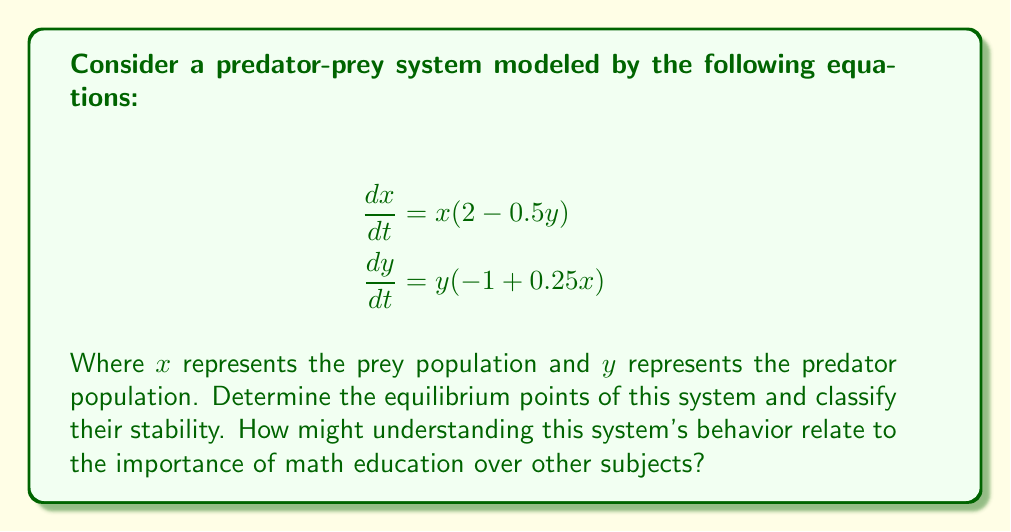What is the answer to this math problem? 1. Find the equilibrium points by setting both equations to zero:

   $$x(2 - 0.5y) = 0$$
   $$y(-1 + 0.25x) = 0$$

2. Solve these equations:
   a) From the first equation, either $x = 0$ or $2 - 0.5y = 0$
   b) From the second equation, either $y = 0$ or $-1 + 0.25x = 0$

3. Combining these conditions, we get two equilibrium points:
   - $(0, 0)$
   - $(4, 4)$

4. To classify stability, we need to find the Jacobian matrix:

   $$J = \begin{bmatrix}
   \frac{\partial}{\partial x}(x(2-0.5y)) & \frac{\partial}{\partial y}(x(2-0.5y)) \\
   \frac{\partial}{\partial x}(y(-1+0.25x)) & \frac{\partial}{\partial y}(y(-1+0.25x))
   \end{bmatrix}$$

   $$J = \begin{bmatrix}
   2-0.5y & -0.5x \\
   0.25y & -1+0.25x
   \end{bmatrix}$$

5. Evaluate J at (0, 0):
   
   $$J_{(0,0)} = \begin{bmatrix}
   2 & 0 \\
   0 & -1
   \end{bmatrix}$$

   Eigenvalues: $\lambda_1 = 2$, $\lambda_2 = -1$
   Since $\lambda_1 > 0$, (0, 0) is an unstable saddle point.

6. Evaluate J at (4, 4):

   $$J_{(4,4)} = \begin{bmatrix}
   0 & -2 \\
   1 & 0
   \end{bmatrix}$$

   Eigenvalues: $\lambda = \pm i\sqrt{2}$
   Since both eigenvalues are purely imaginary, (4, 4) is a center (neutrally stable).

7. This system demonstrates the importance of mathematical modeling in understanding complex real-world phenomena, showcasing the practical applications of math education.
Answer: Equilibrium points: (0, 0) and (4, 4). (0, 0) is an unstable saddle point; (4, 4) is a neutrally stable center. 